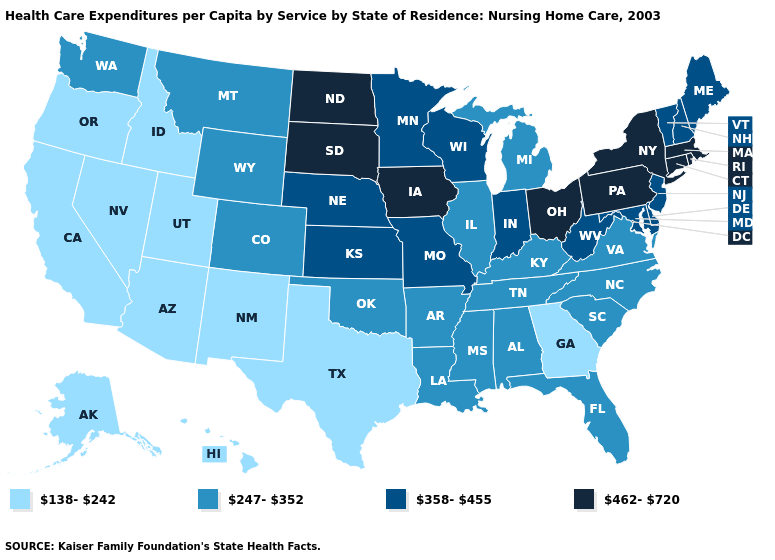What is the value of Michigan?
Answer briefly. 247-352. What is the highest value in states that border Maryland?
Give a very brief answer. 462-720. Does Tennessee have the lowest value in the South?
Short answer required. No. Which states have the lowest value in the South?
Give a very brief answer. Georgia, Texas. What is the lowest value in states that border Louisiana?
Answer briefly. 138-242. Which states hav the highest value in the Northeast?
Answer briefly. Connecticut, Massachusetts, New York, Pennsylvania, Rhode Island. What is the value of Massachusetts?
Answer briefly. 462-720. Does Rhode Island have the highest value in the Northeast?
Answer briefly. Yes. What is the highest value in the Northeast ?
Concise answer only. 462-720. Does Michigan have the lowest value in the USA?
Keep it brief. No. Is the legend a continuous bar?
Short answer required. No. Does Pennsylvania have the lowest value in the USA?
Answer briefly. No. What is the value of Arizona?
Keep it brief. 138-242. What is the value of Kansas?
Answer briefly. 358-455. Does the first symbol in the legend represent the smallest category?
Quick response, please. Yes. 